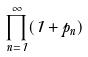Convert formula to latex. <formula><loc_0><loc_0><loc_500><loc_500>\prod _ { n = 1 } ^ { \infty } ( 1 + p _ { n } )</formula> 